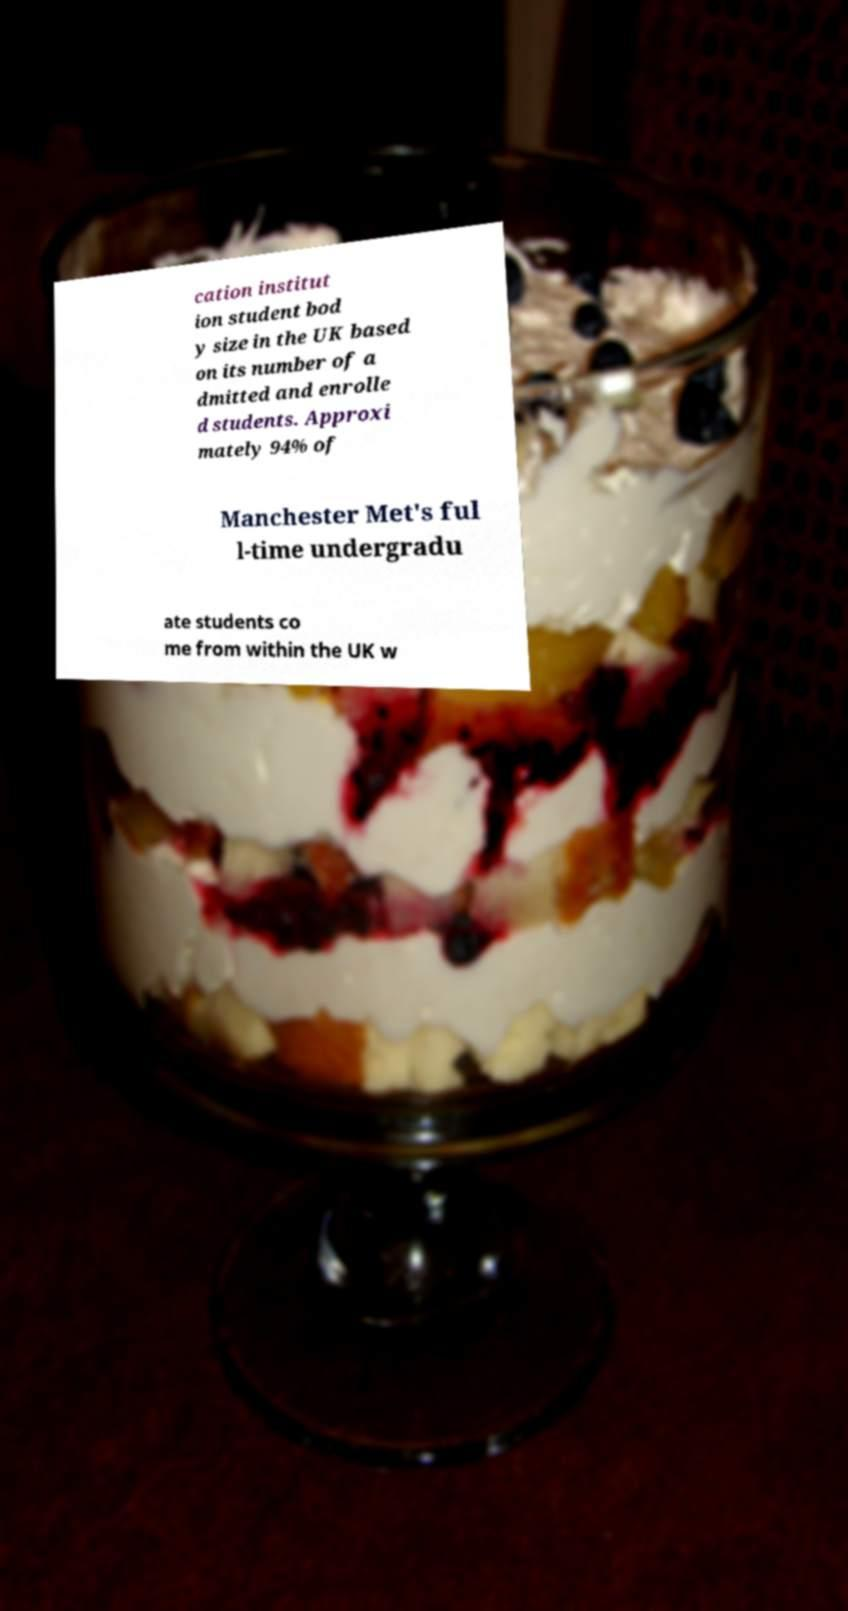There's text embedded in this image that I need extracted. Can you transcribe it verbatim? cation institut ion student bod y size in the UK based on its number of a dmitted and enrolle d students. Approxi mately 94% of Manchester Met's ful l-time undergradu ate students co me from within the UK w 